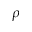<formula> <loc_0><loc_0><loc_500><loc_500>\rho</formula> 